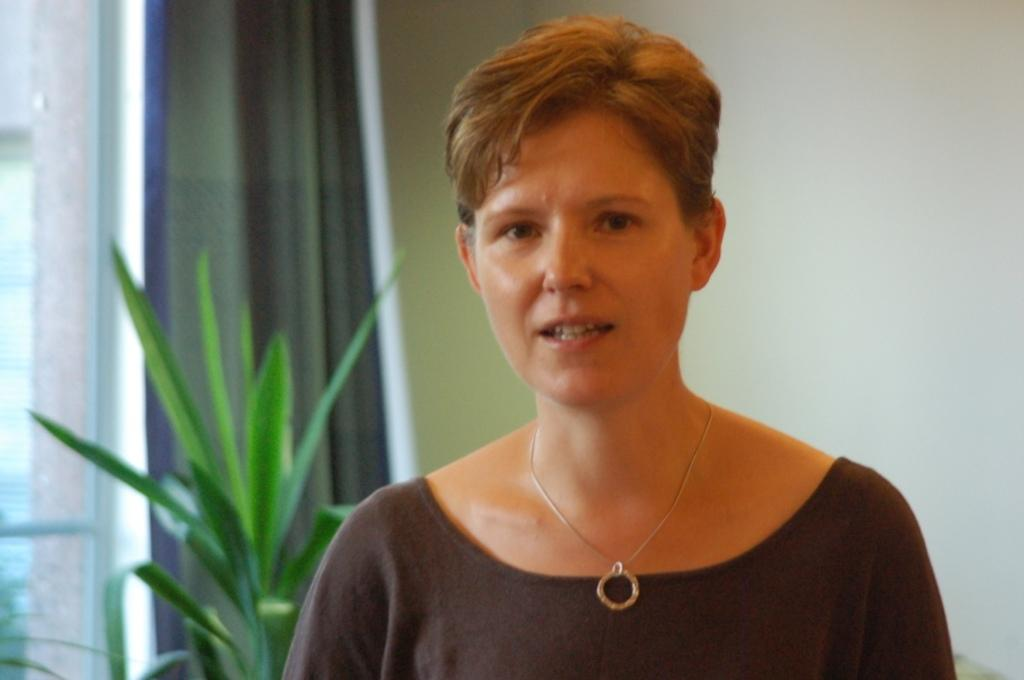What is the main subject in the image? There is a lady standing in the image. What is located beside the lady? There is a plant beside the lady. What can be seen in the background of the image? There is a wall in the background of the image. What type of bed can be seen in the image? There is no bed present in the image. 